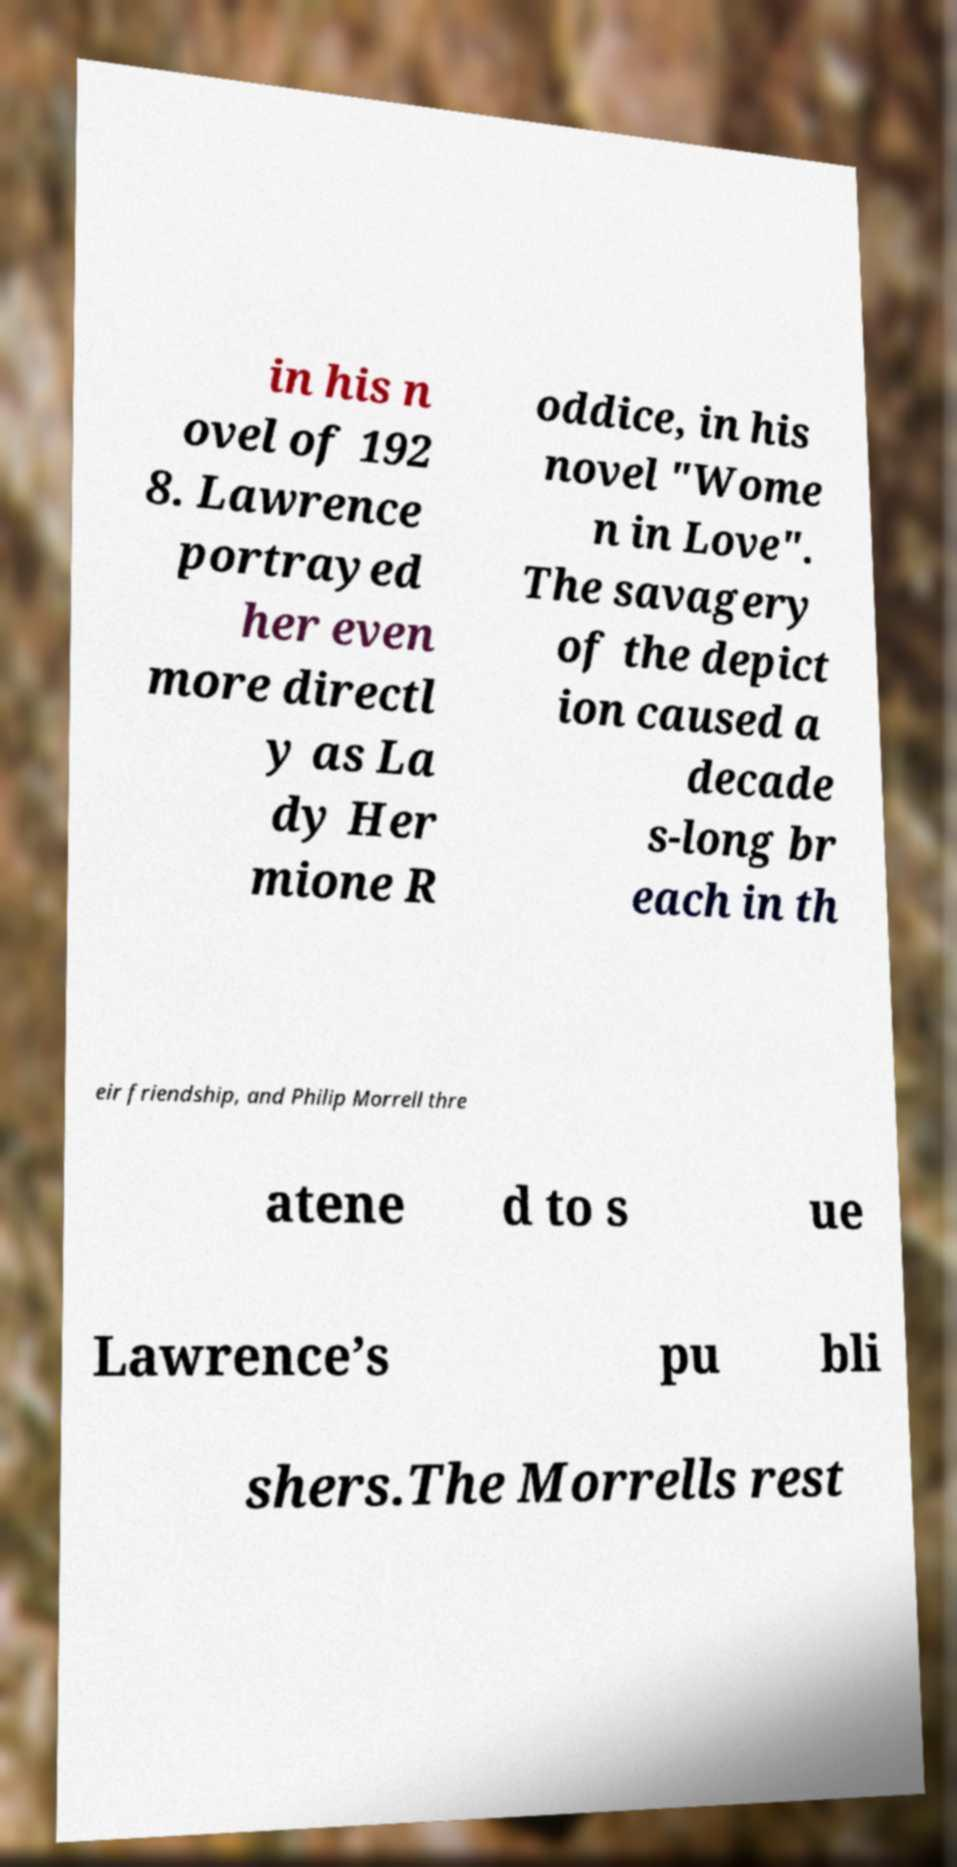There's text embedded in this image that I need extracted. Can you transcribe it verbatim? in his n ovel of 192 8. Lawrence portrayed her even more directl y as La dy Her mione R oddice, in his novel "Wome n in Love". The savagery of the depict ion caused a decade s-long br each in th eir friendship, and Philip Morrell thre atene d to s ue Lawrence’s pu bli shers.The Morrells rest 